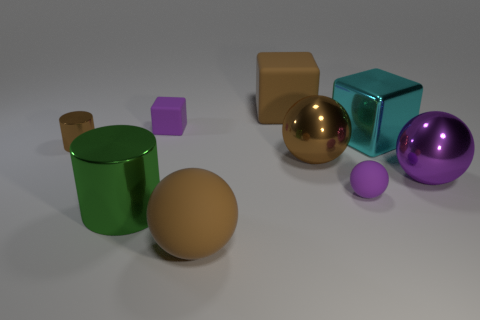Subtract 1 cubes. How many cubes are left? 2 Subtract all spheres. How many objects are left? 5 Add 1 brown cylinders. How many objects exist? 10 Subtract all cyan spheres. Subtract all red blocks. How many spheres are left? 4 Subtract all big cyan metal cubes. Subtract all brown rubber objects. How many objects are left? 6 Add 2 blocks. How many blocks are left? 5 Add 8 small cylinders. How many small cylinders exist? 9 Subtract 0 green balls. How many objects are left? 9 